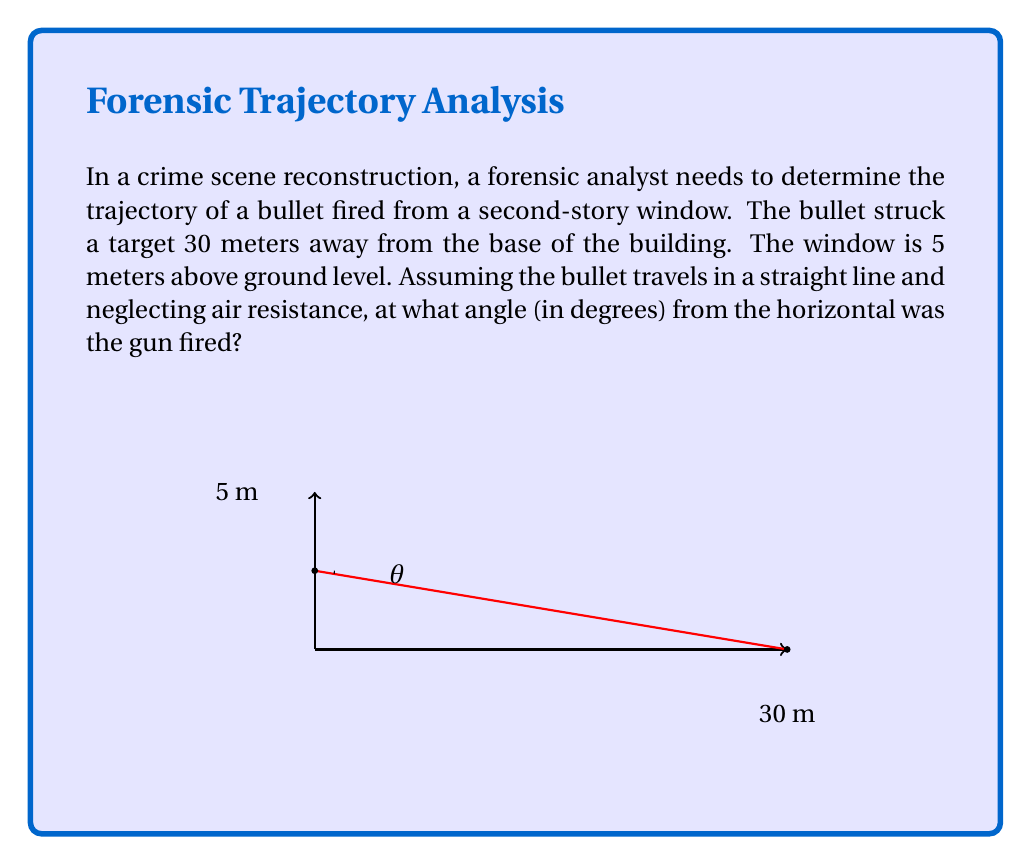What is the answer to this math problem? Let's approach this step-by-step using trigonometry:

1) We can treat this as a right triangle problem. The bullet's trajectory forms the hypotenuse of the triangle.

2) We know two sides of this triangle:
   - The horizontal distance (adjacent side) = 30 meters
   - The vertical distance (opposite side) = 5 meters

3) We need to find the angle $\theta$ between the horizontal and the trajectory.

4) In a right triangle, $\tan(\theta) = \frac{\text{opposite}}{\text{adjacent}}$

5) Therefore:

   $$\tan(\theta) = \frac{5}{30} = \frac{1}{6}$$

6) To find $\theta$, we need to take the inverse tangent (arctangent) of both sides:

   $$\theta = \arctan(\frac{1}{6})$$

7) Using a calculator or computing software:

   $$\theta \approx 9.46232221°$$

8) Rounding to two decimal places:

   $$\theta \approx 9.46°$$
Answer: $9.46°$ 